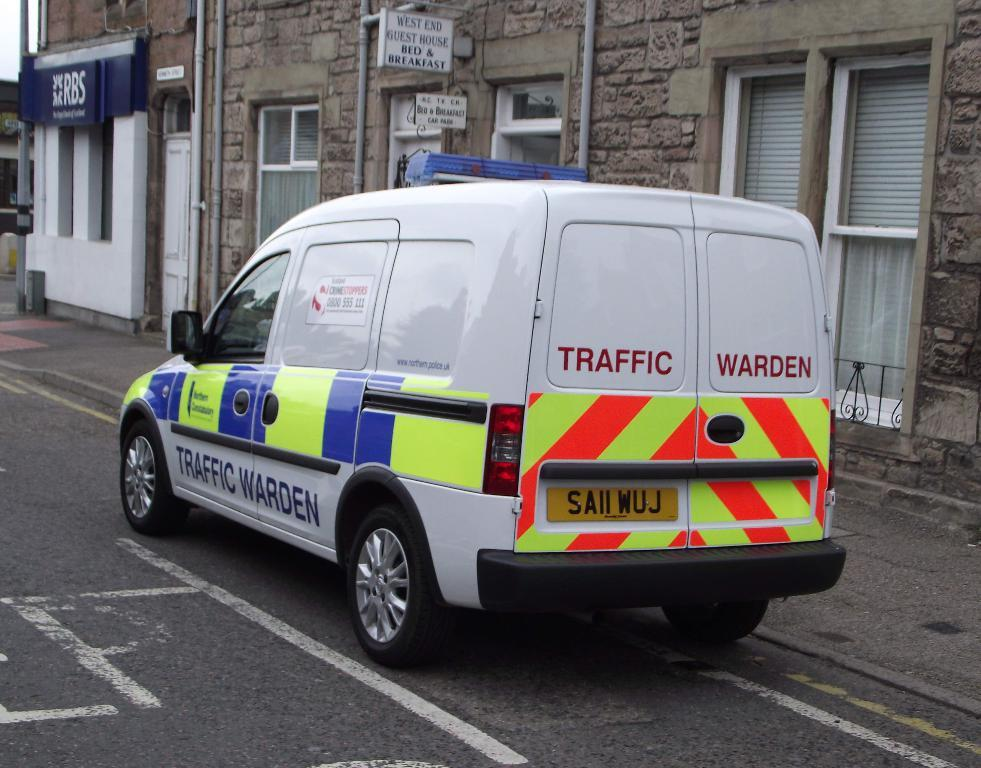<image>
Render a clear and concise summary of the photo. the words traffic warden are on the back of a van 